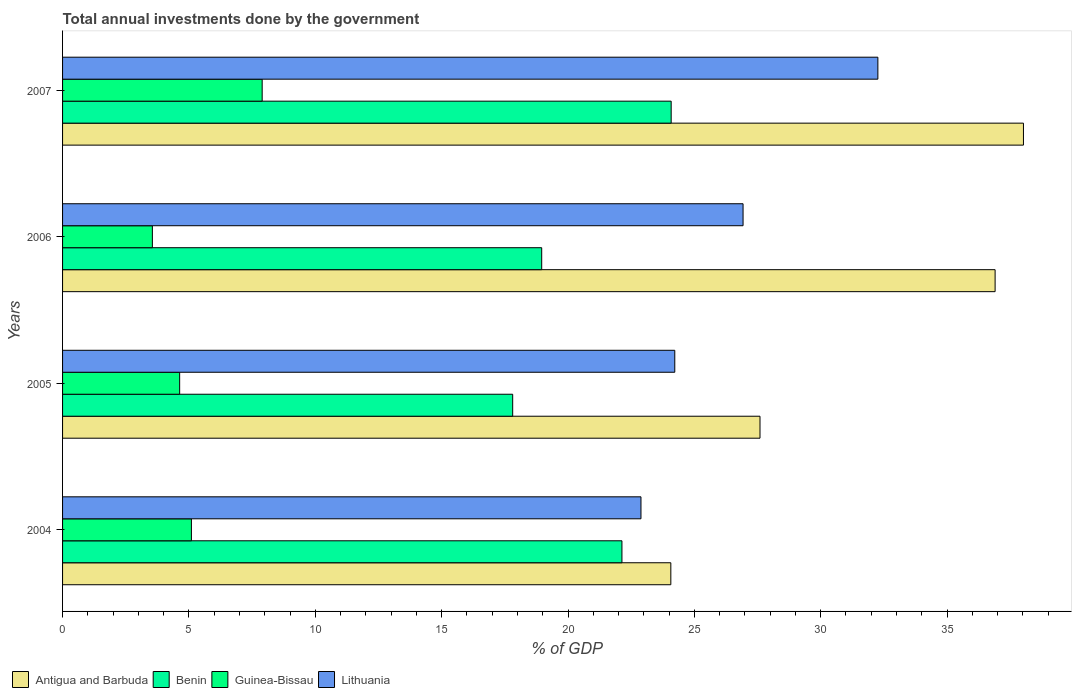How many different coloured bars are there?
Your answer should be compact. 4. Are the number of bars per tick equal to the number of legend labels?
Provide a succinct answer. Yes. How many bars are there on the 4th tick from the top?
Make the answer very short. 4. How many bars are there on the 4th tick from the bottom?
Keep it short and to the point. 4. What is the label of the 1st group of bars from the top?
Keep it short and to the point. 2007. What is the total annual investments done by the government in Lithuania in 2007?
Give a very brief answer. 32.26. Across all years, what is the maximum total annual investments done by the government in Lithuania?
Keep it short and to the point. 32.26. Across all years, what is the minimum total annual investments done by the government in Antigua and Barbuda?
Offer a very short reply. 24.07. What is the total total annual investments done by the government in Benin in the graph?
Make the answer very short. 82.99. What is the difference between the total annual investments done by the government in Benin in 2004 and that in 2005?
Provide a short and direct response. 4.32. What is the difference between the total annual investments done by the government in Lithuania in 2006 and the total annual investments done by the government in Benin in 2007?
Provide a short and direct response. 2.84. What is the average total annual investments done by the government in Lithuania per year?
Your response must be concise. 26.58. In the year 2005, what is the difference between the total annual investments done by the government in Benin and total annual investments done by the government in Antigua and Barbuda?
Your response must be concise. -9.79. In how many years, is the total annual investments done by the government in Benin greater than 4 %?
Make the answer very short. 4. What is the ratio of the total annual investments done by the government in Benin in 2005 to that in 2007?
Keep it short and to the point. 0.74. What is the difference between the highest and the second highest total annual investments done by the government in Benin?
Provide a short and direct response. 1.95. What is the difference between the highest and the lowest total annual investments done by the government in Guinea-Bissau?
Make the answer very short. 4.34. Is the sum of the total annual investments done by the government in Lithuania in 2005 and 2007 greater than the maximum total annual investments done by the government in Antigua and Barbuda across all years?
Ensure brevity in your answer.  Yes. What does the 2nd bar from the top in 2006 represents?
Give a very brief answer. Guinea-Bissau. What does the 1st bar from the bottom in 2004 represents?
Give a very brief answer. Antigua and Barbuda. Are all the bars in the graph horizontal?
Provide a short and direct response. Yes. How many years are there in the graph?
Ensure brevity in your answer.  4. What is the difference between two consecutive major ticks on the X-axis?
Your response must be concise. 5. Are the values on the major ticks of X-axis written in scientific E-notation?
Keep it short and to the point. No. Does the graph contain any zero values?
Provide a succinct answer. No. How many legend labels are there?
Keep it short and to the point. 4. What is the title of the graph?
Keep it short and to the point. Total annual investments done by the government. What is the label or title of the X-axis?
Your answer should be compact. % of GDP. What is the % of GDP in Antigua and Barbuda in 2004?
Your answer should be compact. 24.07. What is the % of GDP of Benin in 2004?
Your response must be concise. 22.13. What is the % of GDP of Guinea-Bissau in 2004?
Your answer should be very brief. 5.1. What is the % of GDP of Lithuania in 2004?
Keep it short and to the point. 22.89. What is the % of GDP of Antigua and Barbuda in 2005?
Ensure brevity in your answer.  27.6. What is the % of GDP in Benin in 2005?
Provide a short and direct response. 17.81. What is the % of GDP in Guinea-Bissau in 2005?
Your response must be concise. 4.63. What is the % of GDP in Lithuania in 2005?
Keep it short and to the point. 24.22. What is the % of GDP in Antigua and Barbuda in 2006?
Make the answer very short. 36.9. What is the % of GDP of Benin in 2006?
Offer a terse response. 18.96. What is the % of GDP of Guinea-Bissau in 2006?
Offer a very short reply. 3.55. What is the % of GDP in Lithuania in 2006?
Make the answer very short. 26.93. What is the % of GDP in Antigua and Barbuda in 2007?
Offer a very short reply. 38.02. What is the % of GDP of Benin in 2007?
Give a very brief answer. 24.08. What is the % of GDP of Guinea-Bissau in 2007?
Your answer should be very brief. 7.9. What is the % of GDP in Lithuania in 2007?
Keep it short and to the point. 32.26. Across all years, what is the maximum % of GDP in Antigua and Barbuda?
Your answer should be compact. 38.02. Across all years, what is the maximum % of GDP of Benin?
Your answer should be compact. 24.08. Across all years, what is the maximum % of GDP of Guinea-Bissau?
Your answer should be very brief. 7.9. Across all years, what is the maximum % of GDP of Lithuania?
Ensure brevity in your answer.  32.26. Across all years, what is the minimum % of GDP in Antigua and Barbuda?
Provide a short and direct response. 24.07. Across all years, what is the minimum % of GDP of Benin?
Keep it short and to the point. 17.81. Across all years, what is the minimum % of GDP of Guinea-Bissau?
Offer a terse response. 3.55. Across all years, what is the minimum % of GDP in Lithuania?
Your answer should be compact. 22.89. What is the total % of GDP in Antigua and Barbuda in the graph?
Your answer should be very brief. 126.59. What is the total % of GDP in Benin in the graph?
Your answer should be very brief. 82.99. What is the total % of GDP in Guinea-Bissau in the graph?
Keep it short and to the point. 21.18. What is the total % of GDP of Lithuania in the graph?
Make the answer very short. 106.3. What is the difference between the % of GDP in Antigua and Barbuda in 2004 and that in 2005?
Make the answer very short. -3.53. What is the difference between the % of GDP in Benin in 2004 and that in 2005?
Provide a short and direct response. 4.32. What is the difference between the % of GDP of Guinea-Bissau in 2004 and that in 2005?
Your response must be concise. 0.47. What is the difference between the % of GDP of Lithuania in 2004 and that in 2005?
Keep it short and to the point. -1.34. What is the difference between the % of GDP in Antigua and Barbuda in 2004 and that in 2006?
Your answer should be very brief. -12.83. What is the difference between the % of GDP in Benin in 2004 and that in 2006?
Your response must be concise. 3.17. What is the difference between the % of GDP in Guinea-Bissau in 2004 and that in 2006?
Make the answer very short. 1.54. What is the difference between the % of GDP of Lithuania in 2004 and that in 2006?
Make the answer very short. -4.04. What is the difference between the % of GDP in Antigua and Barbuda in 2004 and that in 2007?
Ensure brevity in your answer.  -13.95. What is the difference between the % of GDP in Benin in 2004 and that in 2007?
Your answer should be very brief. -1.95. What is the difference between the % of GDP in Lithuania in 2004 and that in 2007?
Offer a terse response. -9.37. What is the difference between the % of GDP of Antigua and Barbuda in 2005 and that in 2006?
Ensure brevity in your answer.  -9.3. What is the difference between the % of GDP in Benin in 2005 and that in 2006?
Give a very brief answer. -1.15. What is the difference between the % of GDP of Guinea-Bissau in 2005 and that in 2006?
Your answer should be compact. 1.08. What is the difference between the % of GDP of Lithuania in 2005 and that in 2006?
Your answer should be compact. -2.7. What is the difference between the % of GDP in Antigua and Barbuda in 2005 and that in 2007?
Make the answer very short. -10.42. What is the difference between the % of GDP in Benin in 2005 and that in 2007?
Offer a terse response. -6.27. What is the difference between the % of GDP of Guinea-Bissau in 2005 and that in 2007?
Give a very brief answer. -3.27. What is the difference between the % of GDP in Lithuania in 2005 and that in 2007?
Offer a very short reply. -8.04. What is the difference between the % of GDP in Antigua and Barbuda in 2006 and that in 2007?
Your answer should be compact. -1.12. What is the difference between the % of GDP in Benin in 2006 and that in 2007?
Your answer should be compact. -5.12. What is the difference between the % of GDP of Guinea-Bissau in 2006 and that in 2007?
Offer a very short reply. -4.34. What is the difference between the % of GDP in Lithuania in 2006 and that in 2007?
Give a very brief answer. -5.33. What is the difference between the % of GDP of Antigua and Barbuda in 2004 and the % of GDP of Benin in 2005?
Offer a very short reply. 6.26. What is the difference between the % of GDP in Antigua and Barbuda in 2004 and the % of GDP in Guinea-Bissau in 2005?
Provide a succinct answer. 19.44. What is the difference between the % of GDP in Antigua and Barbuda in 2004 and the % of GDP in Lithuania in 2005?
Provide a succinct answer. -0.16. What is the difference between the % of GDP in Benin in 2004 and the % of GDP in Guinea-Bissau in 2005?
Provide a succinct answer. 17.5. What is the difference between the % of GDP of Benin in 2004 and the % of GDP of Lithuania in 2005?
Provide a short and direct response. -2.09. What is the difference between the % of GDP of Guinea-Bissau in 2004 and the % of GDP of Lithuania in 2005?
Provide a short and direct response. -19.13. What is the difference between the % of GDP in Antigua and Barbuda in 2004 and the % of GDP in Benin in 2006?
Offer a terse response. 5.11. What is the difference between the % of GDP of Antigua and Barbuda in 2004 and the % of GDP of Guinea-Bissau in 2006?
Give a very brief answer. 20.51. What is the difference between the % of GDP in Antigua and Barbuda in 2004 and the % of GDP in Lithuania in 2006?
Offer a terse response. -2.86. What is the difference between the % of GDP in Benin in 2004 and the % of GDP in Guinea-Bissau in 2006?
Make the answer very short. 18.58. What is the difference between the % of GDP of Benin in 2004 and the % of GDP of Lithuania in 2006?
Your answer should be very brief. -4.79. What is the difference between the % of GDP of Guinea-Bissau in 2004 and the % of GDP of Lithuania in 2006?
Your response must be concise. -21.83. What is the difference between the % of GDP in Antigua and Barbuda in 2004 and the % of GDP in Benin in 2007?
Your response must be concise. -0.01. What is the difference between the % of GDP of Antigua and Barbuda in 2004 and the % of GDP of Guinea-Bissau in 2007?
Offer a very short reply. 16.17. What is the difference between the % of GDP of Antigua and Barbuda in 2004 and the % of GDP of Lithuania in 2007?
Make the answer very short. -8.19. What is the difference between the % of GDP in Benin in 2004 and the % of GDP in Guinea-Bissau in 2007?
Your answer should be very brief. 14.24. What is the difference between the % of GDP of Benin in 2004 and the % of GDP of Lithuania in 2007?
Your response must be concise. -10.13. What is the difference between the % of GDP in Guinea-Bissau in 2004 and the % of GDP in Lithuania in 2007?
Make the answer very short. -27.16. What is the difference between the % of GDP of Antigua and Barbuda in 2005 and the % of GDP of Benin in 2006?
Your answer should be very brief. 8.64. What is the difference between the % of GDP of Antigua and Barbuda in 2005 and the % of GDP of Guinea-Bissau in 2006?
Your answer should be compact. 24.04. What is the difference between the % of GDP in Antigua and Barbuda in 2005 and the % of GDP in Lithuania in 2006?
Provide a short and direct response. 0.67. What is the difference between the % of GDP in Benin in 2005 and the % of GDP in Guinea-Bissau in 2006?
Your answer should be very brief. 14.26. What is the difference between the % of GDP of Benin in 2005 and the % of GDP of Lithuania in 2006?
Provide a short and direct response. -9.12. What is the difference between the % of GDP of Guinea-Bissau in 2005 and the % of GDP of Lithuania in 2006?
Keep it short and to the point. -22.29. What is the difference between the % of GDP of Antigua and Barbuda in 2005 and the % of GDP of Benin in 2007?
Make the answer very short. 3.51. What is the difference between the % of GDP in Antigua and Barbuda in 2005 and the % of GDP in Guinea-Bissau in 2007?
Your answer should be compact. 19.7. What is the difference between the % of GDP in Antigua and Barbuda in 2005 and the % of GDP in Lithuania in 2007?
Give a very brief answer. -4.66. What is the difference between the % of GDP of Benin in 2005 and the % of GDP of Guinea-Bissau in 2007?
Provide a short and direct response. 9.91. What is the difference between the % of GDP in Benin in 2005 and the % of GDP in Lithuania in 2007?
Your answer should be compact. -14.45. What is the difference between the % of GDP of Guinea-Bissau in 2005 and the % of GDP of Lithuania in 2007?
Keep it short and to the point. -27.63. What is the difference between the % of GDP in Antigua and Barbuda in 2006 and the % of GDP in Benin in 2007?
Your answer should be very brief. 12.82. What is the difference between the % of GDP in Antigua and Barbuda in 2006 and the % of GDP in Guinea-Bissau in 2007?
Your answer should be very brief. 29. What is the difference between the % of GDP in Antigua and Barbuda in 2006 and the % of GDP in Lithuania in 2007?
Offer a terse response. 4.64. What is the difference between the % of GDP of Benin in 2006 and the % of GDP of Guinea-Bissau in 2007?
Your response must be concise. 11.06. What is the difference between the % of GDP of Benin in 2006 and the % of GDP of Lithuania in 2007?
Your answer should be compact. -13.3. What is the difference between the % of GDP in Guinea-Bissau in 2006 and the % of GDP in Lithuania in 2007?
Ensure brevity in your answer.  -28.71. What is the average % of GDP of Antigua and Barbuda per year?
Provide a succinct answer. 31.65. What is the average % of GDP in Benin per year?
Give a very brief answer. 20.75. What is the average % of GDP of Guinea-Bissau per year?
Provide a short and direct response. 5.3. What is the average % of GDP of Lithuania per year?
Provide a succinct answer. 26.58. In the year 2004, what is the difference between the % of GDP in Antigua and Barbuda and % of GDP in Benin?
Make the answer very short. 1.93. In the year 2004, what is the difference between the % of GDP in Antigua and Barbuda and % of GDP in Guinea-Bissau?
Keep it short and to the point. 18.97. In the year 2004, what is the difference between the % of GDP in Antigua and Barbuda and % of GDP in Lithuania?
Offer a terse response. 1.18. In the year 2004, what is the difference between the % of GDP in Benin and % of GDP in Guinea-Bissau?
Ensure brevity in your answer.  17.04. In the year 2004, what is the difference between the % of GDP in Benin and % of GDP in Lithuania?
Make the answer very short. -0.75. In the year 2004, what is the difference between the % of GDP in Guinea-Bissau and % of GDP in Lithuania?
Provide a succinct answer. -17.79. In the year 2005, what is the difference between the % of GDP in Antigua and Barbuda and % of GDP in Benin?
Your answer should be compact. 9.79. In the year 2005, what is the difference between the % of GDP in Antigua and Barbuda and % of GDP in Guinea-Bissau?
Provide a succinct answer. 22.96. In the year 2005, what is the difference between the % of GDP of Antigua and Barbuda and % of GDP of Lithuania?
Offer a very short reply. 3.37. In the year 2005, what is the difference between the % of GDP of Benin and % of GDP of Guinea-Bissau?
Keep it short and to the point. 13.18. In the year 2005, what is the difference between the % of GDP of Benin and % of GDP of Lithuania?
Your answer should be very brief. -6.41. In the year 2005, what is the difference between the % of GDP in Guinea-Bissau and % of GDP in Lithuania?
Provide a short and direct response. -19.59. In the year 2006, what is the difference between the % of GDP in Antigua and Barbuda and % of GDP in Benin?
Offer a terse response. 17.94. In the year 2006, what is the difference between the % of GDP in Antigua and Barbuda and % of GDP in Guinea-Bissau?
Provide a short and direct response. 33.35. In the year 2006, what is the difference between the % of GDP in Antigua and Barbuda and % of GDP in Lithuania?
Your response must be concise. 9.97. In the year 2006, what is the difference between the % of GDP of Benin and % of GDP of Guinea-Bissau?
Your response must be concise. 15.41. In the year 2006, what is the difference between the % of GDP of Benin and % of GDP of Lithuania?
Provide a succinct answer. -7.97. In the year 2006, what is the difference between the % of GDP in Guinea-Bissau and % of GDP in Lithuania?
Keep it short and to the point. -23.37. In the year 2007, what is the difference between the % of GDP of Antigua and Barbuda and % of GDP of Benin?
Ensure brevity in your answer.  13.94. In the year 2007, what is the difference between the % of GDP in Antigua and Barbuda and % of GDP in Guinea-Bissau?
Offer a very short reply. 30.12. In the year 2007, what is the difference between the % of GDP of Antigua and Barbuda and % of GDP of Lithuania?
Offer a terse response. 5.76. In the year 2007, what is the difference between the % of GDP in Benin and % of GDP in Guinea-Bissau?
Provide a short and direct response. 16.18. In the year 2007, what is the difference between the % of GDP of Benin and % of GDP of Lithuania?
Your response must be concise. -8.18. In the year 2007, what is the difference between the % of GDP in Guinea-Bissau and % of GDP in Lithuania?
Offer a very short reply. -24.36. What is the ratio of the % of GDP of Antigua and Barbuda in 2004 to that in 2005?
Your response must be concise. 0.87. What is the ratio of the % of GDP in Benin in 2004 to that in 2005?
Your answer should be compact. 1.24. What is the ratio of the % of GDP of Guinea-Bissau in 2004 to that in 2005?
Give a very brief answer. 1.1. What is the ratio of the % of GDP of Lithuania in 2004 to that in 2005?
Offer a terse response. 0.94. What is the ratio of the % of GDP in Antigua and Barbuda in 2004 to that in 2006?
Your response must be concise. 0.65. What is the ratio of the % of GDP in Benin in 2004 to that in 2006?
Your response must be concise. 1.17. What is the ratio of the % of GDP of Guinea-Bissau in 2004 to that in 2006?
Your answer should be compact. 1.43. What is the ratio of the % of GDP in Lithuania in 2004 to that in 2006?
Your answer should be compact. 0.85. What is the ratio of the % of GDP in Antigua and Barbuda in 2004 to that in 2007?
Give a very brief answer. 0.63. What is the ratio of the % of GDP of Benin in 2004 to that in 2007?
Keep it short and to the point. 0.92. What is the ratio of the % of GDP in Guinea-Bissau in 2004 to that in 2007?
Offer a terse response. 0.65. What is the ratio of the % of GDP in Lithuania in 2004 to that in 2007?
Your answer should be very brief. 0.71. What is the ratio of the % of GDP in Antigua and Barbuda in 2005 to that in 2006?
Give a very brief answer. 0.75. What is the ratio of the % of GDP of Benin in 2005 to that in 2006?
Ensure brevity in your answer.  0.94. What is the ratio of the % of GDP in Guinea-Bissau in 2005 to that in 2006?
Offer a very short reply. 1.3. What is the ratio of the % of GDP in Lithuania in 2005 to that in 2006?
Make the answer very short. 0.9. What is the ratio of the % of GDP in Antigua and Barbuda in 2005 to that in 2007?
Your response must be concise. 0.73. What is the ratio of the % of GDP of Benin in 2005 to that in 2007?
Give a very brief answer. 0.74. What is the ratio of the % of GDP of Guinea-Bissau in 2005 to that in 2007?
Offer a terse response. 0.59. What is the ratio of the % of GDP in Lithuania in 2005 to that in 2007?
Your answer should be compact. 0.75. What is the ratio of the % of GDP of Antigua and Barbuda in 2006 to that in 2007?
Give a very brief answer. 0.97. What is the ratio of the % of GDP of Benin in 2006 to that in 2007?
Your response must be concise. 0.79. What is the ratio of the % of GDP in Guinea-Bissau in 2006 to that in 2007?
Ensure brevity in your answer.  0.45. What is the ratio of the % of GDP in Lithuania in 2006 to that in 2007?
Ensure brevity in your answer.  0.83. What is the difference between the highest and the second highest % of GDP of Antigua and Barbuda?
Keep it short and to the point. 1.12. What is the difference between the highest and the second highest % of GDP in Benin?
Offer a very short reply. 1.95. What is the difference between the highest and the second highest % of GDP in Guinea-Bissau?
Make the answer very short. 2.8. What is the difference between the highest and the second highest % of GDP in Lithuania?
Your answer should be very brief. 5.33. What is the difference between the highest and the lowest % of GDP of Antigua and Barbuda?
Keep it short and to the point. 13.95. What is the difference between the highest and the lowest % of GDP of Benin?
Provide a succinct answer. 6.27. What is the difference between the highest and the lowest % of GDP in Guinea-Bissau?
Your response must be concise. 4.34. What is the difference between the highest and the lowest % of GDP in Lithuania?
Offer a very short reply. 9.37. 